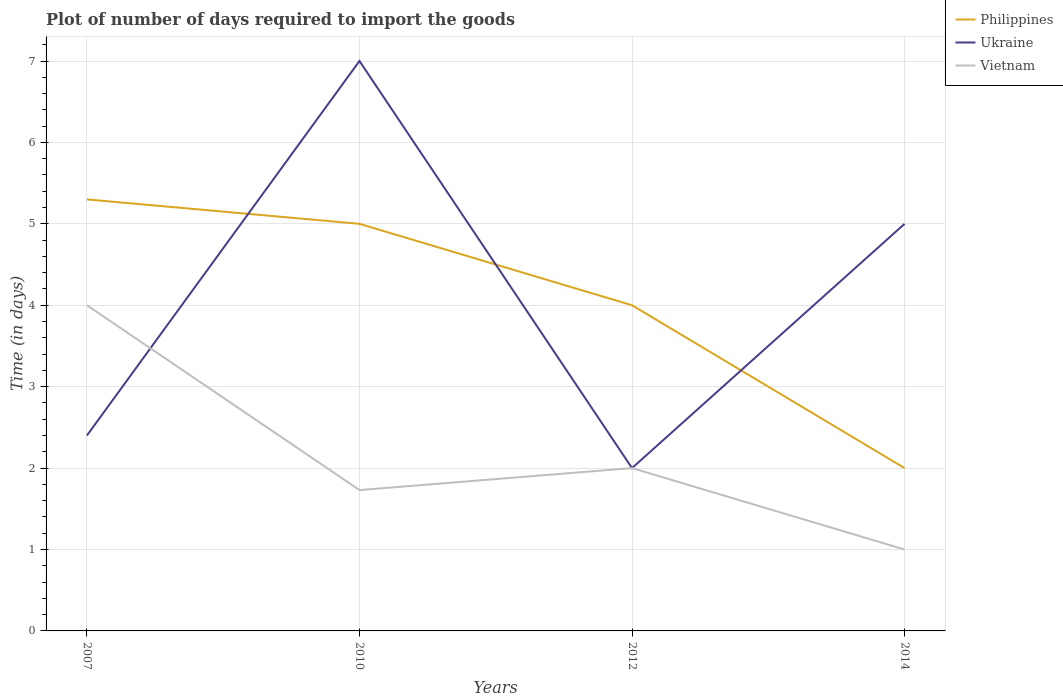How many different coloured lines are there?
Make the answer very short. 3. Is the number of lines equal to the number of legend labels?
Provide a succinct answer. Yes. In which year was the time required to import goods in Ukraine maximum?
Provide a succinct answer. 2012. What is the difference between the highest and the lowest time required to import goods in Philippines?
Make the answer very short. 2. Is the time required to import goods in Philippines strictly greater than the time required to import goods in Vietnam over the years?
Provide a succinct answer. No. How many years are there in the graph?
Offer a very short reply. 4. Does the graph contain grids?
Offer a terse response. Yes. How are the legend labels stacked?
Keep it short and to the point. Vertical. What is the title of the graph?
Give a very brief answer. Plot of number of days required to import the goods. Does "Sierra Leone" appear as one of the legend labels in the graph?
Keep it short and to the point. No. What is the label or title of the Y-axis?
Offer a very short reply. Time (in days). What is the Time (in days) in Vietnam in 2007?
Provide a short and direct response. 4. What is the Time (in days) of Philippines in 2010?
Make the answer very short. 5. What is the Time (in days) in Ukraine in 2010?
Make the answer very short. 7. What is the Time (in days) in Vietnam in 2010?
Provide a succinct answer. 1.73. What is the Time (in days) of Vietnam in 2014?
Give a very brief answer. 1. Across all years, what is the minimum Time (in days) in Philippines?
Your answer should be compact. 2. What is the total Time (in days) in Philippines in the graph?
Give a very brief answer. 16.3. What is the total Time (in days) in Vietnam in the graph?
Ensure brevity in your answer.  8.73. What is the difference between the Time (in days) of Vietnam in 2007 and that in 2010?
Your response must be concise. 2.27. What is the difference between the Time (in days) of Ukraine in 2007 and that in 2012?
Offer a terse response. 0.4. What is the difference between the Time (in days) of Vietnam in 2007 and that in 2014?
Offer a terse response. 3. What is the difference between the Time (in days) in Vietnam in 2010 and that in 2012?
Offer a terse response. -0.27. What is the difference between the Time (in days) of Ukraine in 2010 and that in 2014?
Make the answer very short. 2. What is the difference between the Time (in days) in Vietnam in 2010 and that in 2014?
Give a very brief answer. 0.73. What is the difference between the Time (in days) of Philippines in 2012 and that in 2014?
Offer a terse response. 2. What is the difference between the Time (in days) of Ukraine in 2012 and that in 2014?
Your response must be concise. -3. What is the difference between the Time (in days) in Vietnam in 2012 and that in 2014?
Provide a succinct answer. 1. What is the difference between the Time (in days) in Philippines in 2007 and the Time (in days) in Ukraine in 2010?
Provide a short and direct response. -1.7. What is the difference between the Time (in days) of Philippines in 2007 and the Time (in days) of Vietnam in 2010?
Your answer should be compact. 3.57. What is the difference between the Time (in days) of Ukraine in 2007 and the Time (in days) of Vietnam in 2010?
Offer a very short reply. 0.67. What is the difference between the Time (in days) in Philippines in 2007 and the Time (in days) in Vietnam in 2012?
Your answer should be very brief. 3.3. What is the difference between the Time (in days) of Ukraine in 2007 and the Time (in days) of Vietnam in 2012?
Keep it short and to the point. 0.4. What is the difference between the Time (in days) in Philippines in 2010 and the Time (in days) in Vietnam in 2012?
Ensure brevity in your answer.  3. What is the difference between the Time (in days) in Philippines in 2010 and the Time (in days) in Ukraine in 2014?
Your answer should be compact. 0. What is the difference between the Time (in days) of Philippines in 2010 and the Time (in days) of Vietnam in 2014?
Provide a succinct answer. 4. What is the difference between the Time (in days) in Philippines in 2012 and the Time (in days) in Vietnam in 2014?
Your answer should be very brief. 3. What is the difference between the Time (in days) of Ukraine in 2012 and the Time (in days) of Vietnam in 2014?
Provide a succinct answer. 1. What is the average Time (in days) of Philippines per year?
Your answer should be very brief. 4.08. What is the average Time (in days) of Ukraine per year?
Give a very brief answer. 4.1. What is the average Time (in days) of Vietnam per year?
Give a very brief answer. 2.18. In the year 2007, what is the difference between the Time (in days) in Philippines and Time (in days) in Ukraine?
Keep it short and to the point. 2.9. In the year 2007, what is the difference between the Time (in days) in Philippines and Time (in days) in Vietnam?
Give a very brief answer. 1.3. In the year 2007, what is the difference between the Time (in days) of Ukraine and Time (in days) of Vietnam?
Your answer should be compact. -1.6. In the year 2010, what is the difference between the Time (in days) of Philippines and Time (in days) of Vietnam?
Keep it short and to the point. 3.27. In the year 2010, what is the difference between the Time (in days) of Ukraine and Time (in days) of Vietnam?
Provide a succinct answer. 5.27. In the year 2012, what is the difference between the Time (in days) in Philippines and Time (in days) in Ukraine?
Provide a succinct answer. 2. In the year 2012, what is the difference between the Time (in days) of Ukraine and Time (in days) of Vietnam?
Give a very brief answer. 0. In the year 2014, what is the difference between the Time (in days) of Philippines and Time (in days) of Ukraine?
Keep it short and to the point. -3. What is the ratio of the Time (in days) of Philippines in 2007 to that in 2010?
Your answer should be compact. 1.06. What is the ratio of the Time (in days) in Ukraine in 2007 to that in 2010?
Your answer should be very brief. 0.34. What is the ratio of the Time (in days) in Vietnam in 2007 to that in 2010?
Offer a very short reply. 2.31. What is the ratio of the Time (in days) in Philippines in 2007 to that in 2012?
Provide a short and direct response. 1.32. What is the ratio of the Time (in days) in Vietnam in 2007 to that in 2012?
Provide a succinct answer. 2. What is the ratio of the Time (in days) of Philippines in 2007 to that in 2014?
Ensure brevity in your answer.  2.65. What is the ratio of the Time (in days) of Ukraine in 2007 to that in 2014?
Provide a short and direct response. 0.48. What is the ratio of the Time (in days) in Vietnam in 2007 to that in 2014?
Offer a terse response. 4. What is the ratio of the Time (in days) in Ukraine in 2010 to that in 2012?
Your answer should be very brief. 3.5. What is the ratio of the Time (in days) of Vietnam in 2010 to that in 2012?
Provide a succinct answer. 0.86. What is the ratio of the Time (in days) in Philippines in 2010 to that in 2014?
Keep it short and to the point. 2.5. What is the ratio of the Time (in days) of Ukraine in 2010 to that in 2014?
Offer a terse response. 1.4. What is the ratio of the Time (in days) of Vietnam in 2010 to that in 2014?
Your answer should be compact. 1.73. What is the ratio of the Time (in days) in Ukraine in 2012 to that in 2014?
Provide a short and direct response. 0.4. What is the ratio of the Time (in days) in Vietnam in 2012 to that in 2014?
Provide a succinct answer. 2. What is the difference between the highest and the second highest Time (in days) in Vietnam?
Offer a terse response. 2. What is the difference between the highest and the lowest Time (in days) in Ukraine?
Your answer should be very brief. 5. 